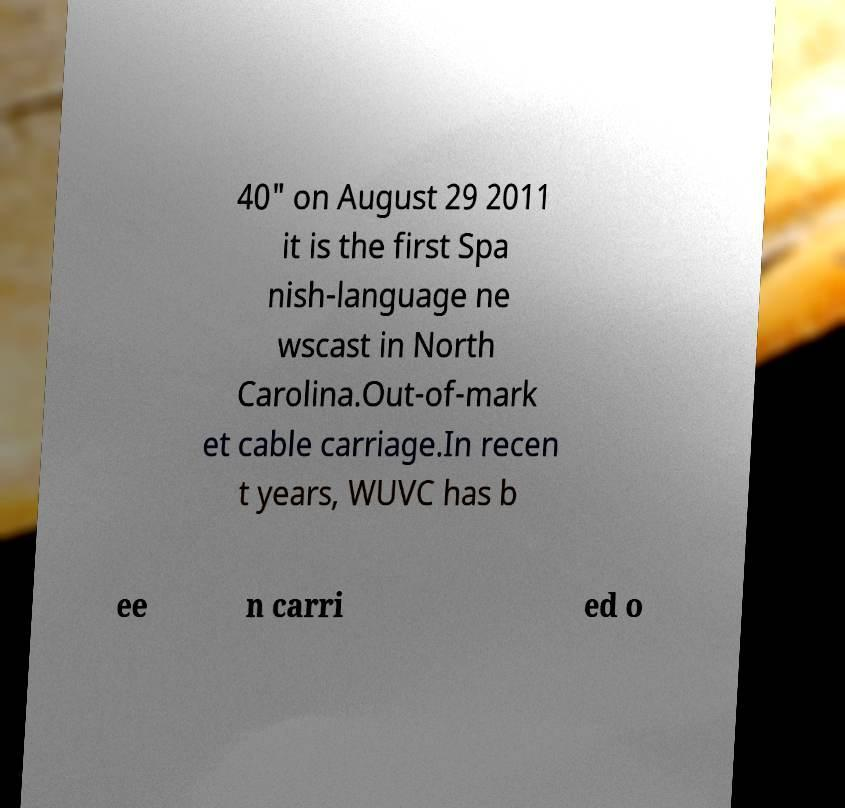What messages or text are displayed in this image? I need them in a readable, typed format. 40" on August 29 2011 it is the first Spa nish-language ne wscast in North Carolina.Out-of-mark et cable carriage.In recen t years, WUVC has b ee n carri ed o 